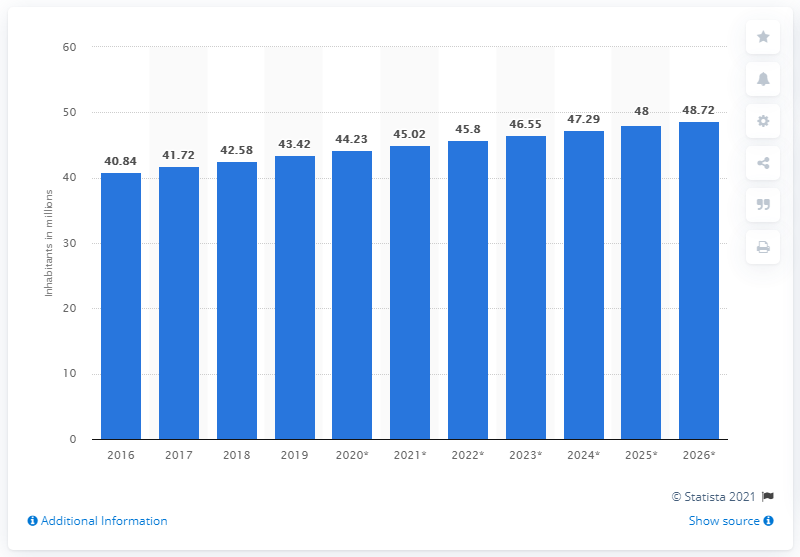Indicate a few pertinent items in this graphic. The population of Algeria in 2019 was 43.42 million. 